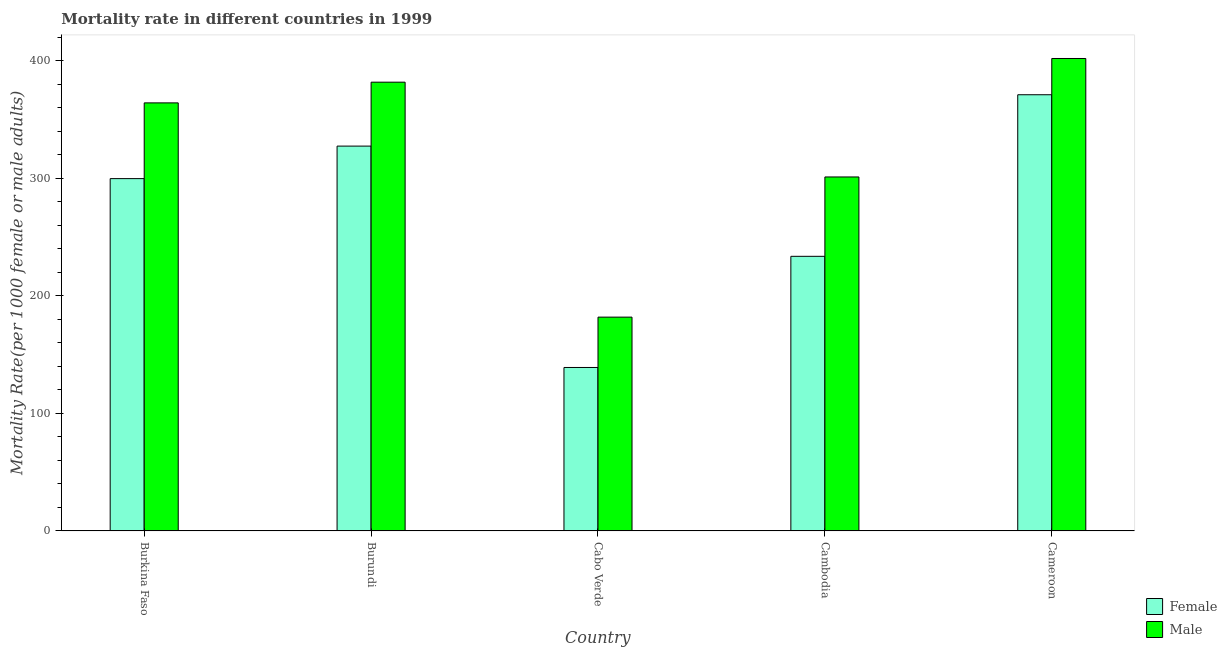How many different coloured bars are there?
Give a very brief answer. 2. Are the number of bars per tick equal to the number of legend labels?
Your response must be concise. Yes. How many bars are there on the 3rd tick from the right?
Provide a succinct answer. 2. What is the label of the 1st group of bars from the left?
Offer a terse response. Burkina Faso. In how many cases, is the number of bars for a given country not equal to the number of legend labels?
Your response must be concise. 0. What is the female mortality rate in Cameroon?
Provide a succinct answer. 370.92. Across all countries, what is the maximum male mortality rate?
Your answer should be compact. 401.74. Across all countries, what is the minimum male mortality rate?
Your answer should be very brief. 181.81. In which country was the female mortality rate maximum?
Your response must be concise. Cameroon. In which country was the male mortality rate minimum?
Provide a short and direct response. Cabo Verde. What is the total male mortality rate in the graph?
Ensure brevity in your answer.  1630.15. What is the difference between the female mortality rate in Burkina Faso and that in Cameroon?
Your answer should be compact. -71.32. What is the difference between the male mortality rate in Cambodia and the female mortality rate in Cameroon?
Keep it short and to the point. -69.91. What is the average male mortality rate per country?
Ensure brevity in your answer.  326.03. What is the difference between the female mortality rate and male mortality rate in Burundi?
Keep it short and to the point. -54.35. What is the ratio of the female mortality rate in Cabo Verde to that in Cameroon?
Provide a succinct answer. 0.37. What is the difference between the highest and the second highest male mortality rate?
Your answer should be compact. 20.14. What is the difference between the highest and the lowest female mortality rate?
Ensure brevity in your answer.  231.91. In how many countries, is the male mortality rate greater than the average male mortality rate taken over all countries?
Offer a terse response. 3. How many bars are there?
Offer a very short reply. 10. Does the graph contain any zero values?
Keep it short and to the point. No. What is the title of the graph?
Give a very brief answer. Mortality rate in different countries in 1999. What is the label or title of the Y-axis?
Your answer should be compact. Mortality Rate(per 1000 female or male adults). What is the Mortality Rate(per 1000 female or male adults) of Female in Burkina Faso?
Offer a very short reply. 299.59. What is the Mortality Rate(per 1000 female or male adults) of Male in Burkina Faso?
Give a very brief answer. 364. What is the Mortality Rate(per 1000 female or male adults) of Female in Burundi?
Your answer should be very brief. 327.25. What is the Mortality Rate(per 1000 female or male adults) in Male in Burundi?
Offer a very short reply. 381.6. What is the Mortality Rate(per 1000 female or male adults) in Female in Cabo Verde?
Your response must be concise. 139. What is the Mortality Rate(per 1000 female or male adults) in Male in Cabo Verde?
Your answer should be very brief. 181.81. What is the Mortality Rate(per 1000 female or male adults) of Female in Cambodia?
Provide a short and direct response. 233.51. What is the Mortality Rate(per 1000 female or male adults) in Male in Cambodia?
Your answer should be very brief. 301. What is the Mortality Rate(per 1000 female or male adults) in Female in Cameroon?
Offer a very short reply. 370.92. What is the Mortality Rate(per 1000 female or male adults) of Male in Cameroon?
Your answer should be compact. 401.74. Across all countries, what is the maximum Mortality Rate(per 1000 female or male adults) in Female?
Offer a very short reply. 370.92. Across all countries, what is the maximum Mortality Rate(per 1000 female or male adults) of Male?
Give a very brief answer. 401.74. Across all countries, what is the minimum Mortality Rate(per 1000 female or male adults) of Female?
Provide a short and direct response. 139. Across all countries, what is the minimum Mortality Rate(per 1000 female or male adults) of Male?
Ensure brevity in your answer.  181.81. What is the total Mortality Rate(per 1000 female or male adults) of Female in the graph?
Your response must be concise. 1370.28. What is the total Mortality Rate(per 1000 female or male adults) of Male in the graph?
Keep it short and to the point. 1630.15. What is the difference between the Mortality Rate(per 1000 female or male adults) of Female in Burkina Faso and that in Burundi?
Your response must be concise. -27.65. What is the difference between the Mortality Rate(per 1000 female or male adults) in Male in Burkina Faso and that in Burundi?
Your answer should be compact. -17.61. What is the difference between the Mortality Rate(per 1000 female or male adults) of Female in Burkina Faso and that in Cabo Verde?
Provide a succinct answer. 160.59. What is the difference between the Mortality Rate(per 1000 female or male adults) of Male in Burkina Faso and that in Cabo Verde?
Provide a short and direct response. 182.18. What is the difference between the Mortality Rate(per 1000 female or male adults) of Female in Burkina Faso and that in Cambodia?
Offer a very short reply. 66.08. What is the difference between the Mortality Rate(per 1000 female or male adults) of Male in Burkina Faso and that in Cambodia?
Make the answer very short. 62.99. What is the difference between the Mortality Rate(per 1000 female or male adults) of Female in Burkina Faso and that in Cameroon?
Ensure brevity in your answer.  -71.32. What is the difference between the Mortality Rate(per 1000 female or male adults) in Male in Burkina Faso and that in Cameroon?
Offer a terse response. -37.74. What is the difference between the Mortality Rate(per 1000 female or male adults) in Female in Burundi and that in Cabo Verde?
Offer a terse response. 188.24. What is the difference between the Mortality Rate(per 1000 female or male adults) of Male in Burundi and that in Cabo Verde?
Provide a succinct answer. 199.79. What is the difference between the Mortality Rate(per 1000 female or male adults) in Female in Burundi and that in Cambodia?
Provide a succinct answer. 93.73. What is the difference between the Mortality Rate(per 1000 female or male adults) in Male in Burundi and that in Cambodia?
Your response must be concise. 80.6. What is the difference between the Mortality Rate(per 1000 female or male adults) in Female in Burundi and that in Cameroon?
Provide a short and direct response. -43.67. What is the difference between the Mortality Rate(per 1000 female or male adults) in Male in Burundi and that in Cameroon?
Provide a succinct answer. -20.14. What is the difference between the Mortality Rate(per 1000 female or male adults) in Female in Cabo Verde and that in Cambodia?
Offer a terse response. -94.51. What is the difference between the Mortality Rate(per 1000 female or male adults) in Male in Cabo Verde and that in Cambodia?
Your answer should be very brief. -119.19. What is the difference between the Mortality Rate(per 1000 female or male adults) in Female in Cabo Verde and that in Cameroon?
Provide a short and direct response. -231.91. What is the difference between the Mortality Rate(per 1000 female or male adults) of Male in Cabo Verde and that in Cameroon?
Offer a very short reply. -219.93. What is the difference between the Mortality Rate(per 1000 female or male adults) of Female in Cambodia and that in Cameroon?
Keep it short and to the point. -137.4. What is the difference between the Mortality Rate(per 1000 female or male adults) in Male in Cambodia and that in Cameroon?
Make the answer very short. -100.73. What is the difference between the Mortality Rate(per 1000 female or male adults) of Female in Burkina Faso and the Mortality Rate(per 1000 female or male adults) of Male in Burundi?
Your response must be concise. -82.01. What is the difference between the Mortality Rate(per 1000 female or male adults) of Female in Burkina Faso and the Mortality Rate(per 1000 female or male adults) of Male in Cabo Verde?
Make the answer very short. 117.78. What is the difference between the Mortality Rate(per 1000 female or male adults) of Female in Burkina Faso and the Mortality Rate(per 1000 female or male adults) of Male in Cambodia?
Your answer should be compact. -1.41. What is the difference between the Mortality Rate(per 1000 female or male adults) of Female in Burkina Faso and the Mortality Rate(per 1000 female or male adults) of Male in Cameroon?
Make the answer very short. -102.14. What is the difference between the Mortality Rate(per 1000 female or male adults) of Female in Burundi and the Mortality Rate(per 1000 female or male adults) of Male in Cabo Verde?
Your response must be concise. 145.44. What is the difference between the Mortality Rate(per 1000 female or male adults) of Female in Burundi and the Mortality Rate(per 1000 female or male adults) of Male in Cambodia?
Offer a terse response. 26.25. What is the difference between the Mortality Rate(per 1000 female or male adults) in Female in Burundi and the Mortality Rate(per 1000 female or male adults) in Male in Cameroon?
Provide a short and direct response. -74.49. What is the difference between the Mortality Rate(per 1000 female or male adults) in Female in Cabo Verde and the Mortality Rate(per 1000 female or male adults) in Male in Cambodia?
Keep it short and to the point. -162. What is the difference between the Mortality Rate(per 1000 female or male adults) in Female in Cabo Verde and the Mortality Rate(per 1000 female or male adults) in Male in Cameroon?
Offer a very short reply. -262.73. What is the difference between the Mortality Rate(per 1000 female or male adults) of Female in Cambodia and the Mortality Rate(per 1000 female or male adults) of Male in Cameroon?
Make the answer very short. -168.22. What is the average Mortality Rate(per 1000 female or male adults) in Female per country?
Provide a succinct answer. 274.06. What is the average Mortality Rate(per 1000 female or male adults) in Male per country?
Offer a very short reply. 326.03. What is the difference between the Mortality Rate(per 1000 female or male adults) in Female and Mortality Rate(per 1000 female or male adults) in Male in Burkina Faso?
Make the answer very short. -64.4. What is the difference between the Mortality Rate(per 1000 female or male adults) in Female and Mortality Rate(per 1000 female or male adults) in Male in Burundi?
Make the answer very short. -54.35. What is the difference between the Mortality Rate(per 1000 female or male adults) in Female and Mortality Rate(per 1000 female or male adults) in Male in Cabo Verde?
Your response must be concise. -42.81. What is the difference between the Mortality Rate(per 1000 female or male adults) in Female and Mortality Rate(per 1000 female or male adults) in Male in Cambodia?
Your response must be concise. -67.49. What is the difference between the Mortality Rate(per 1000 female or male adults) in Female and Mortality Rate(per 1000 female or male adults) in Male in Cameroon?
Your answer should be compact. -30.82. What is the ratio of the Mortality Rate(per 1000 female or male adults) of Female in Burkina Faso to that in Burundi?
Offer a terse response. 0.92. What is the ratio of the Mortality Rate(per 1000 female or male adults) in Male in Burkina Faso to that in Burundi?
Your answer should be compact. 0.95. What is the ratio of the Mortality Rate(per 1000 female or male adults) in Female in Burkina Faso to that in Cabo Verde?
Offer a very short reply. 2.16. What is the ratio of the Mortality Rate(per 1000 female or male adults) in Male in Burkina Faso to that in Cabo Verde?
Offer a terse response. 2. What is the ratio of the Mortality Rate(per 1000 female or male adults) of Female in Burkina Faso to that in Cambodia?
Your answer should be compact. 1.28. What is the ratio of the Mortality Rate(per 1000 female or male adults) in Male in Burkina Faso to that in Cambodia?
Keep it short and to the point. 1.21. What is the ratio of the Mortality Rate(per 1000 female or male adults) in Female in Burkina Faso to that in Cameroon?
Keep it short and to the point. 0.81. What is the ratio of the Mortality Rate(per 1000 female or male adults) in Male in Burkina Faso to that in Cameroon?
Keep it short and to the point. 0.91. What is the ratio of the Mortality Rate(per 1000 female or male adults) of Female in Burundi to that in Cabo Verde?
Offer a very short reply. 2.35. What is the ratio of the Mortality Rate(per 1000 female or male adults) in Male in Burundi to that in Cabo Verde?
Your response must be concise. 2.1. What is the ratio of the Mortality Rate(per 1000 female or male adults) in Female in Burundi to that in Cambodia?
Make the answer very short. 1.4. What is the ratio of the Mortality Rate(per 1000 female or male adults) in Male in Burundi to that in Cambodia?
Offer a terse response. 1.27. What is the ratio of the Mortality Rate(per 1000 female or male adults) in Female in Burundi to that in Cameroon?
Offer a very short reply. 0.88. What is the ratio of the Mortality Rate(per 1000 female or male adults) of Male in Burundi to that in Cameroon?
Your answer should be compact. 0.95. What is the ratio of the Mortality Rate(per 1000 female or male adults) in Female in Cabo Verde to that in Cambodia?
Make the answer very short. 0.6. What is the ratio of the Mortality Rate(per 1000 female or male adults) of Male in Cabo Verde to that in Cambodia?
Give a very brief answer. 0.6. What is the ratio of the Mortality Rate(per 1000 female or male adults) in Female in Cabo Verde to that in Cameroon?
Your answer should be compact. 0.37. What is the ratio of the Mortality Rate(per 1000 female or male adults) of Male in Cabo Verde to that in Cameroon?
Your answer should be compact. 0.45. What is the ratio of the Mortality Rate(per 1000 female or male adults) of Female in Cambodia to that in Cameroon?
Keep it short and to the point. 0.63. What is the ratio of the Mortality Rate(per 1000 female or male adults) in Male in Cambodia to that in Cameroon?
Provide a succinct answer. 0.75. What is the difference between the highest and the second highest Mortality Rate(per 1000 female or male adults) in Female?
Your answer should be very brief. 43.67. What is the difference between the highest and the second highest Mortality Rate(per 1000 female or male adults) in Male?
Make the answer very short. 20.14. What is the difference between the highest and the lowest Mortality Rate(per 1000 female or male adults) of Female?
Offer a terse response. 231.91. What is the difference between the highest and the lowest Mortality Rate(per 1000 female or male adults) of Male?
Ensure brevity in your answer.  219.93. 